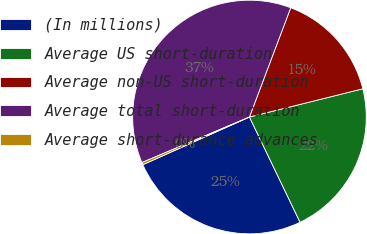<chart> <loc_0><loc_0><loc_500><loc_500><pie_chart><fcel>(In millions)<fcel>Average US short-duration<fcel>Average non-US short-duration<fcel>Average total short-duration<fcel>Average short-durance advances<nl><fcel>25.44%<fcel>21.75%<fcel>15.37%<fcel>37.12%<fcel>0.32%<nl></chart> 